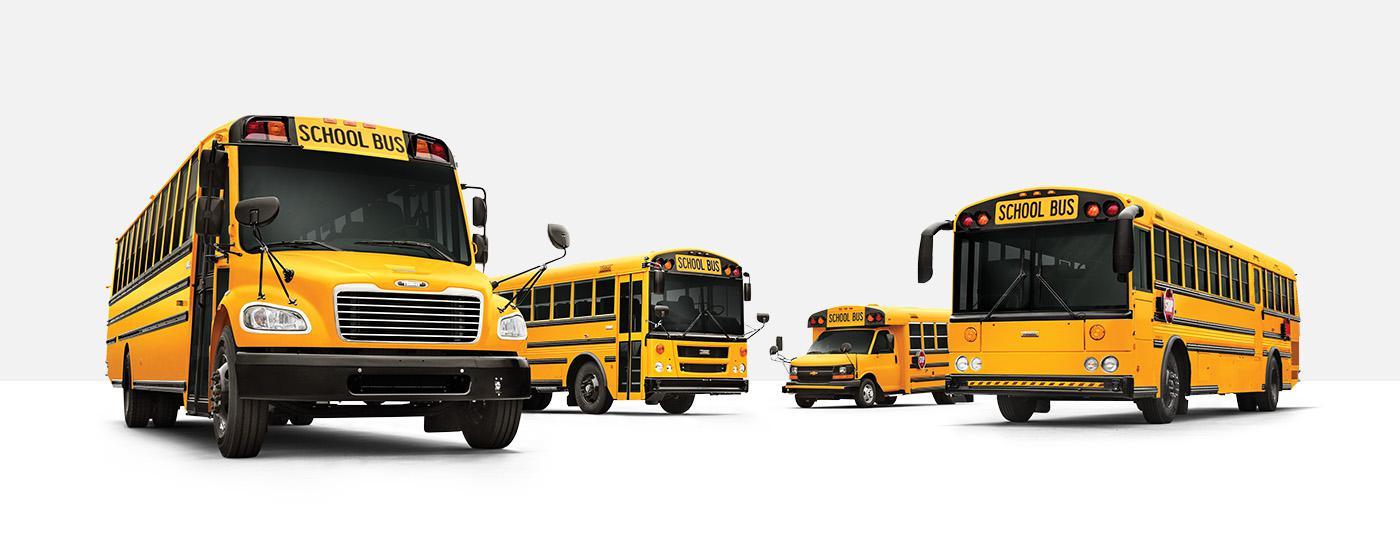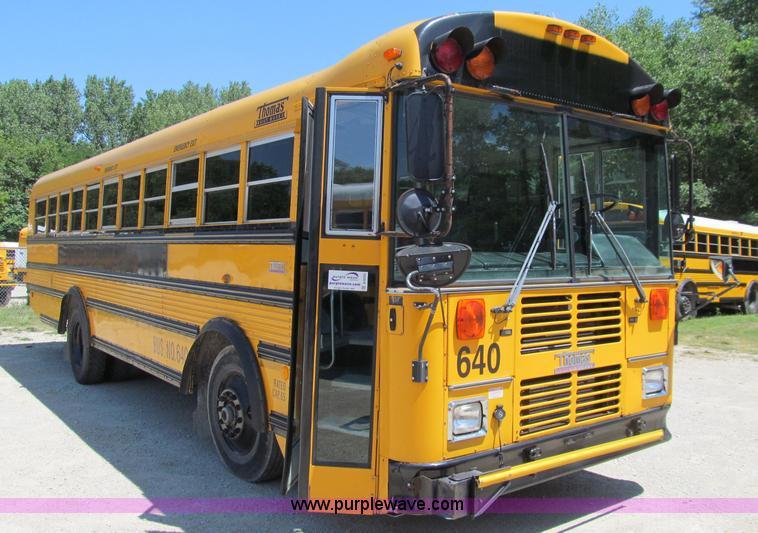The first image is the image on the left, the second image is the image on the right. For the images shown, is this caption "Each image contains at least one flat-fronted yellow bus, and the bus in the right image is angled rightward." true? Answer yes or no. Yes. 